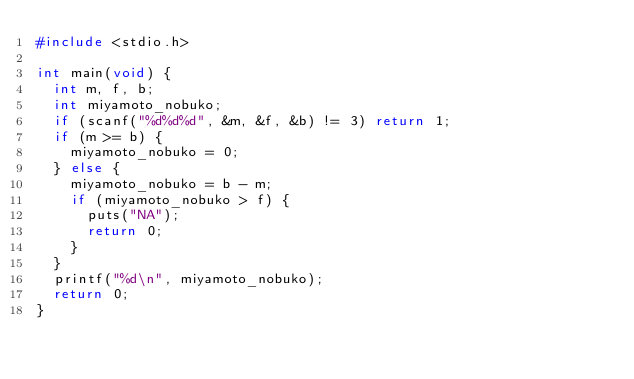<code> <loc_0><loc_0><loc_500><loc_500><_C_>#include <stdio.h>

int main(void) {
	int m, f, b;
	int miyamoto_nobuko;
	if (scanf("%d%d%d", &m, &f, &b) != 3) return 1;
	if (m >= b) {
		miyamoto_nobuko = 0;
	} else {
		miyamoto_nobuko = b - m;
		if (miyamoto_nobuko > f) {
			puts("NA");
			return 0;
		}
	}
	printf("%d\n", miyamoto_nobuko);
	return 0;
}

</code> 